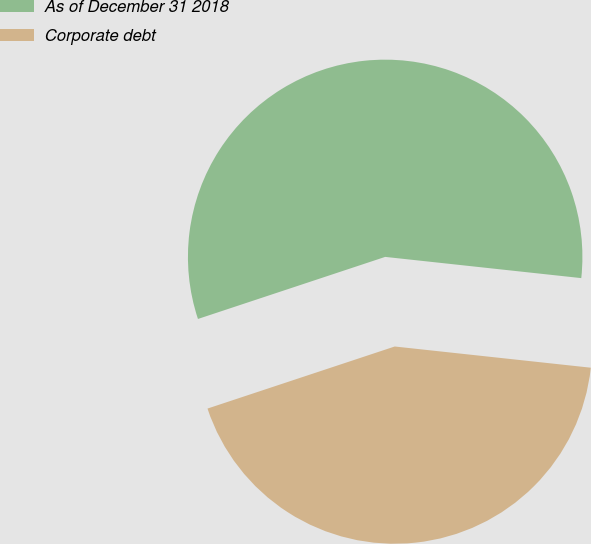<chart> <loc_0><loc_0><loc_500><loc_500><pie_chart><fcel>As of December 31 2018<fcel>Corporate debt<nl><fcel>56.81%<fcel>43.19%<nl></chart> 